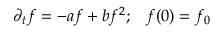<formula> <loc_0><loc_0><loc_500><loc_500>\partial _ { t } f = - a f + b f ^ { 2 } ; \, f ( 0 ) = f _ { 0 }</formula> 